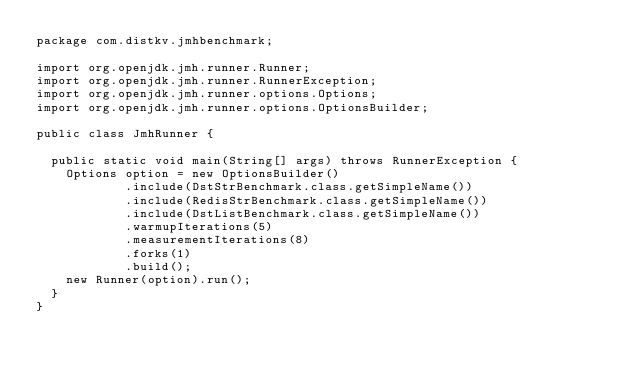<code> <loc_0><loc_0><loc_500><loc_500><_Java_>package com.distkv.jmhbenchmark;

import org.openjdk.jmh.runner.Runner;
import org.openjdk.jmh.runner.RunnerException;
import org.openjdk.jmh.runner.options.Options;
import org.openjdk.jmh.runner.options.OptionsBuilder;

public class JmhRunner {

  public static void main(String[] args) throws RunnerException {
    Options option = new OptionsBuilder()
            .include(DstStrBenchmark.class.getSimpleName())
            .include(RedisStrBenchmark.class.getSimpleName())
            .include(DstListBenchmark.class.getSimpleName())
            .warmupIterations(5)
            .measurementIterations(8)
            .forks(1)
            .build();
    new Runner(option).run();
  }
}
</code> 